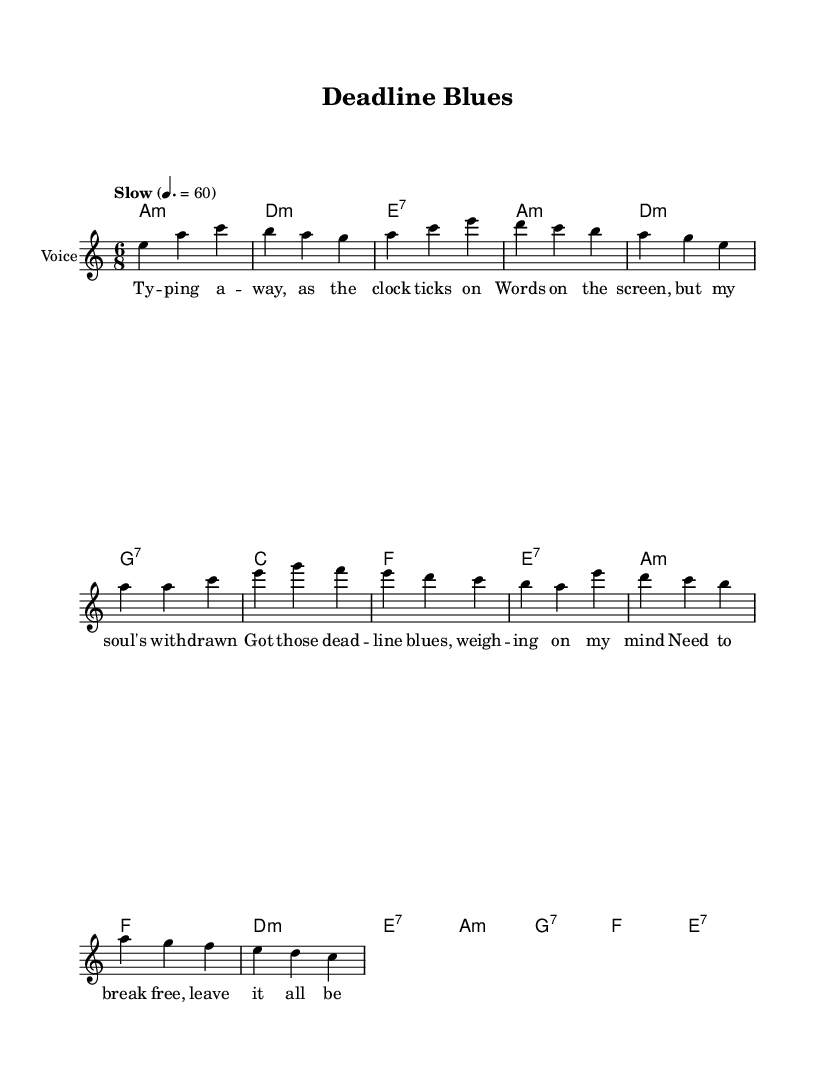What is the key signature of this music? The key signature indicates the scale on which the song is based. In this case, the notation shows "a" minor, which is represented with one sharp (G#) in the scale.
Answer: A minor What is the time signature of this music? The time signature is represented at the beginning of the music sheet, showing the number of beats in each measure. Here, it is written as "6/8", indicating that there are 6 beats per measure and the eighth note gets one beat.
Answer: 6/8 What is the tempo marking for this piece? The tempo marking is indicated on the score, typically in Italian. In this sheet music, "Slow" is provided with a metronome marking of 60 beats per minute, suggesting a relaxed pace.
Answer: Slow How many measures are in the verse section? To find this, we count the measures presented in the melody section corresponding to the verse. The verse melody has a total of 6 measures, as evident from the way the notes are grouped.
Answer: 6 What type of harmony is primarily used in this piece? The harmony section indicates chords used in the song. We can see that the song features minor and seventh chords predominantly, which is characteristic of the blues genre, providing a soulful sound.
Answer: Minor and seventh chords What is the mood conveyed by the lyrics? The lyrics discuss feelings of stress related to deadlines and the desire to unwind, suggesting a mood of introspection and melancholy, which is reflected in the overall blues style.
Answer: Introspection How does the structure of the song reflect a typical blues format? The structure includes verses and a chorus, with a bridge that provides contrast, which follows a standard blues framework often seen in female-led ballads. This pattern promotes both storytelling and emotional expression.
Answer: Verse-Chorus-Bridge 